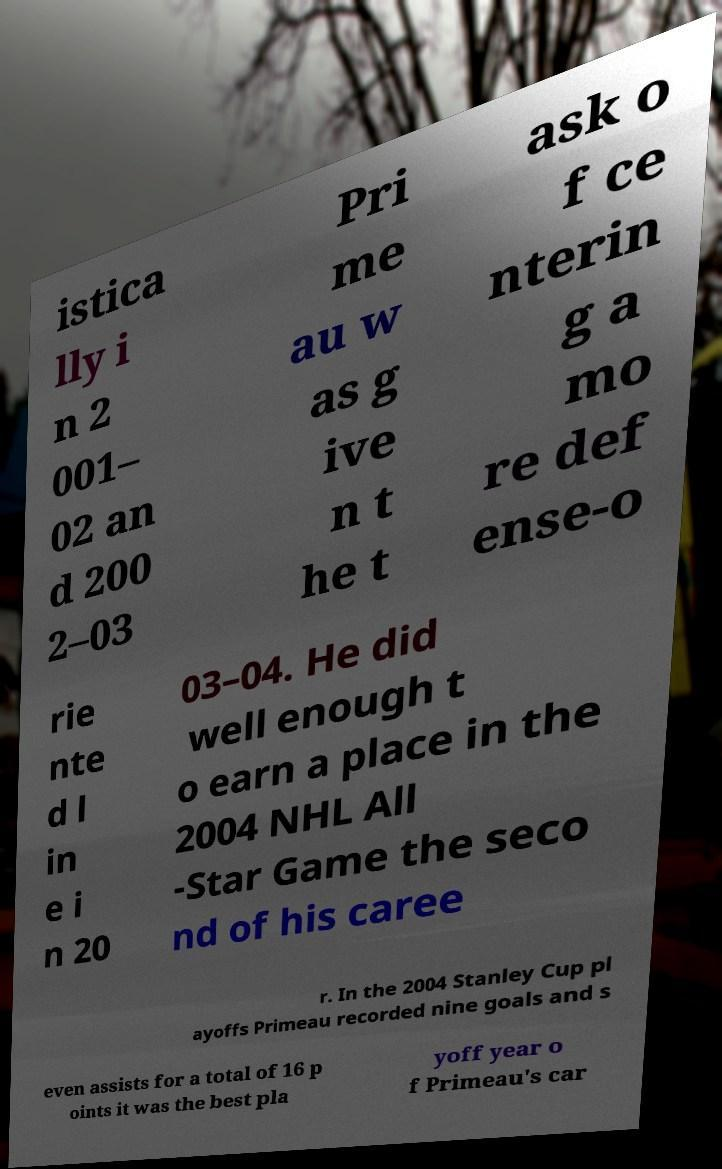Could you extract and type out the text from this image? istica lly i n 2 001– 02 an d 200 2–03 Pri me au w as g ive n t he t ask o f ce nterin g a mo re def ense-o rie nte d l in e i n 20 03–04. He did well enough t o earn a place in the 2004 NHL All -Star Game the seco nd of his caree r. In the 2004 Stanley Cup pl ayoffs Primeau recorded nine goals and s even assists for a total of 16 p oints it was the best pla yoff year o f Primeau's car 